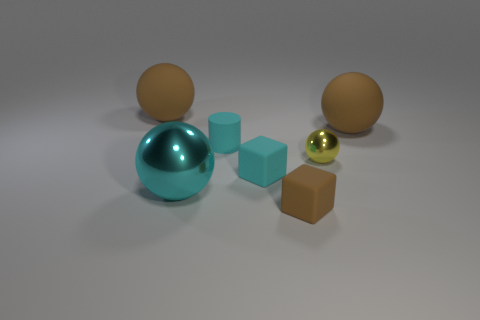Are there an equal number of brown matte balls behind the tiny brown matte block and blocks right of the yellow object? no 